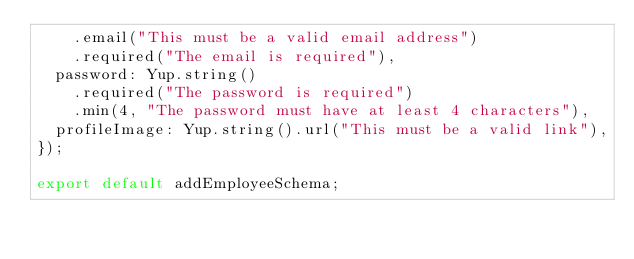<code> <loc_0><loc_0><loc_500><loc_500><_JavaScript_>    .email("This must be a valid email address")
    .required("The email is required"),
  password: Yup.string()
    .required("The password is required")
    .min(4, "The password must have at least 4 characters"),
  profileImage: Yup.string().url("This must be a valid link"),
});

export default addEmployeeSchema;
</code> 